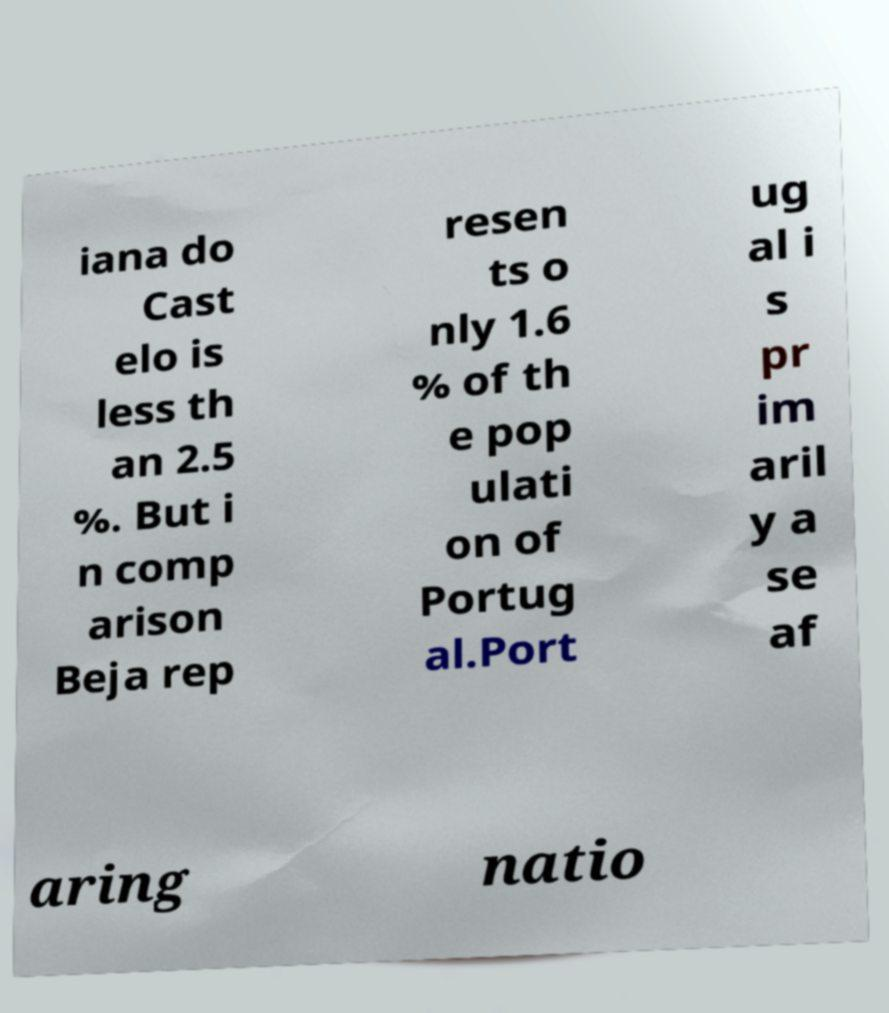Please read and relay the text visible in this image. What does it say? iana do Cast elo is less th an 2.5 %. But i n comp arison Beja rep resen ts o nly 1.6 % of th e pop ulati on of Portug al.Port ug al i s pr im aril y a se af aring natio 